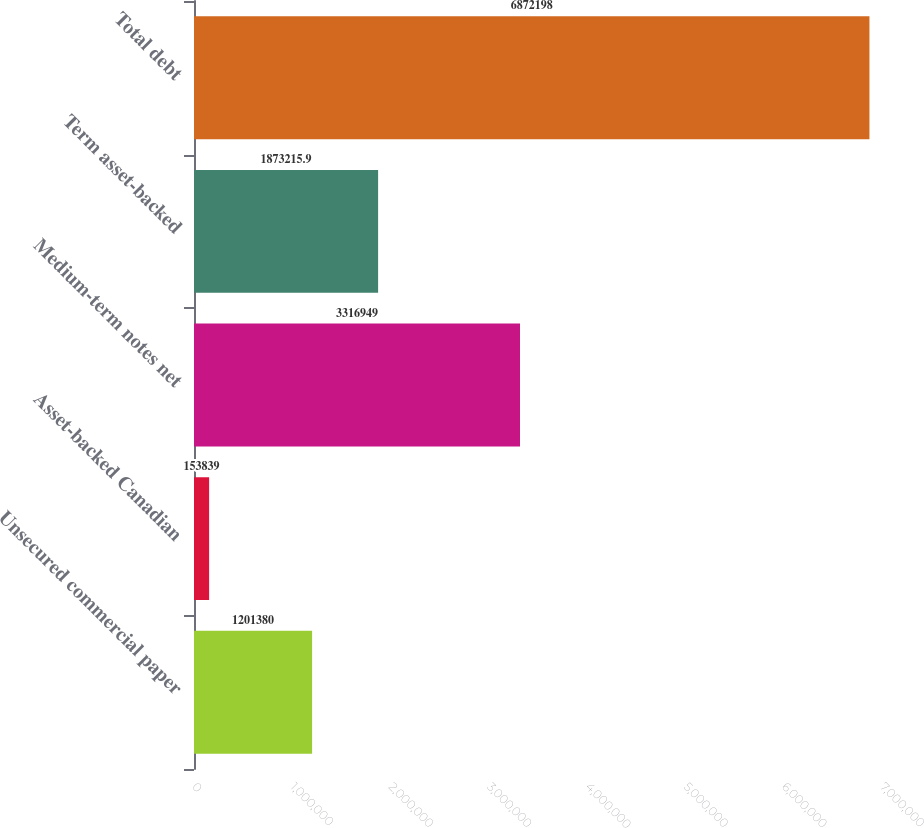<chart> <loc_0><loc_0><loc_500><loc_500><bar_chart><fcel>Unsecured commercial paper<fcel>Asset-backed Canadian<fcel>Medium-term notes net<fcel>Term asset-backed<fcel>Total debt<nl><fcel>1.20138e+06<fcel>153839<fcel>3.31695e+06<fcel>1.87322e+06<fcel>6.8722e+06<nl></chart> 